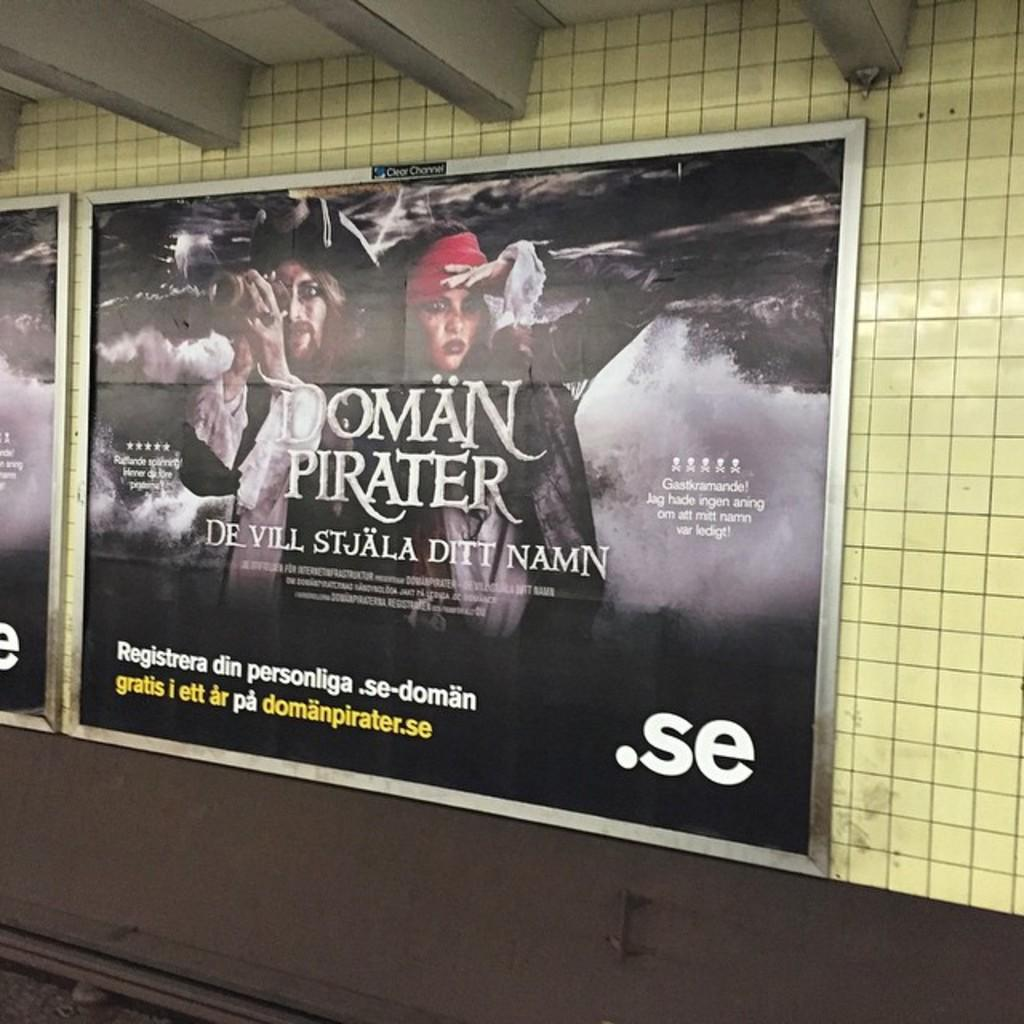What can be seen on the wall in the image? There are posts on the wall in the image. Where is the pen located on the map in the image? There is no pen or map present in the image; only posts on the wall are visible. 